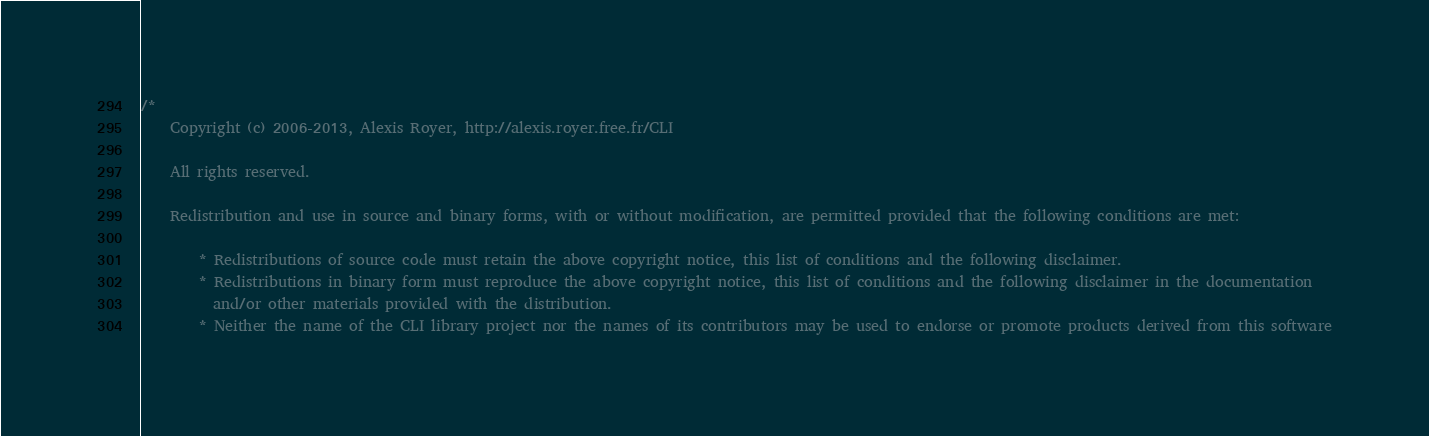Convert code to text. <code><loc_0><loc_0><loc_500><loc_500><_C++_>/*
    Copyright (c) 2006-2013, Alexis Royer, http://alexis.royer.free.fr/CLI

    All rights reserved.

    Redistribution and use in source and binary forms, with or without modification, are permitted provided that the following conditions are met:

        * Redistributions of source code must retain the above copyright notice, this list of conditions and the following disclaimer.
        * Redistributions in binary form must reproduce the above copyright notice, this list of conditions and the following disclaimer in the documentation
          and/or other materials provided with the distribution.
        * Neither the name of the CLI library project nor the names of its contributors may be used to endorse or promote products derived from this software</code> 